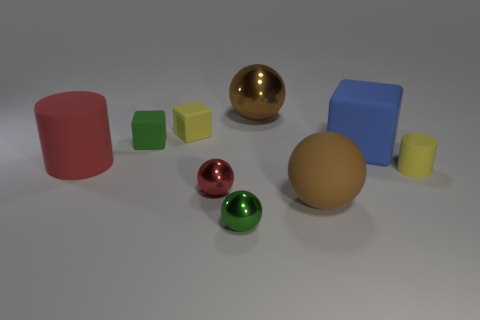Subtract all cylinders. How many objects are left? 7 Subtract 0 blue cylinders. How many objects are left? 9 Subtract all tiny cylinders. Subtract all small red spheres. How many objects are left? 7 Add 5 metal objects. How many metal objects are left? 8 Add 9 red cubes. How many red cubes exist? 9 